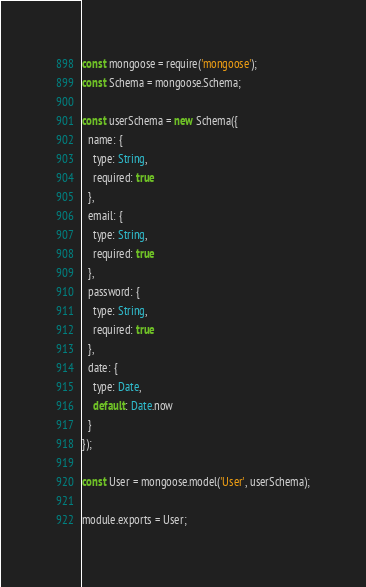Convert code to text. <code><loc_0><loc_0><loc_500><loc_500><_JavaScript_>const mongoose = require('mongoose');
const Schema = mongoose.Schema;

const userSchema = new Schema({
  name: {
    type: String,
    required: true
  },
  email: {
    type: String,
    required: true
  },
  password: {
    type: String,
    required: true
  },
  date: {
    type: Date,
    default: Date.now
  }
});

const User = mongoose.model('User', userSchema);

module.exports = User;</code> 